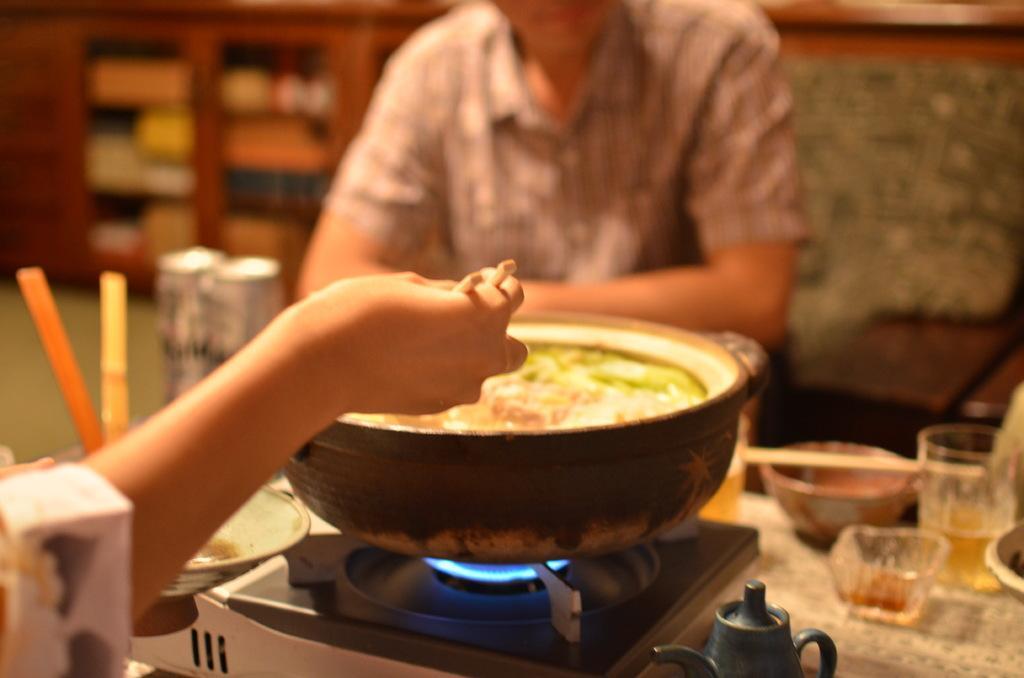How would you summarize this image in a sentence or two? This is a zoomed in picture. In the foreground there is a table on the top of which some items are placed and we can see a utensil placed on the stove. On the left corner there is a hand of a person cooking some food in a utensil. In the background we can see a wooden cabinet containing some items and a person seems to be sitting. 